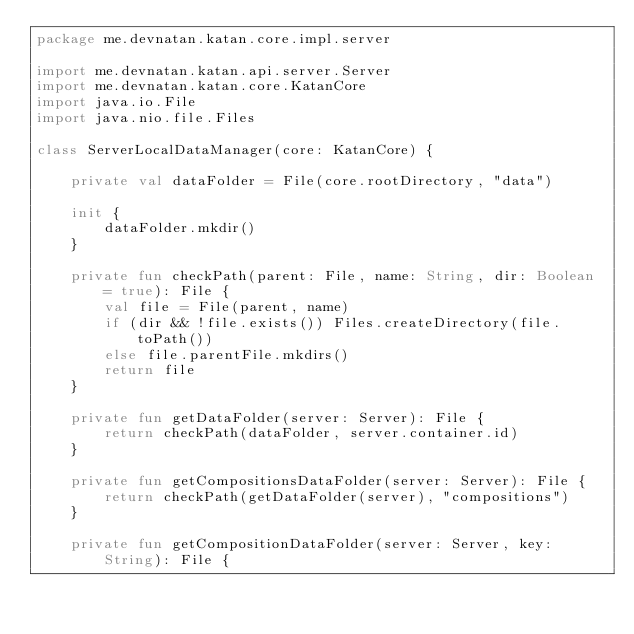<code> <loc_0><loc_0><loc_500><loc_500><_Kotlin_>package me.devnatan.katan.core.impl.server

import me.devnatan.katan.api.server.Server
import me.devnatan.katan.core.KatanCore
import java.io.File
import java.nio.file.Files

class ServerLocalDataManager(core: KatanCore) {

    private val dataFolder = File(core.rootDirectory, "data")

    init {
        dataFolder.mkdir()
    }

    private fun checkPath(parent: File, name: String, dir: Boolean = true): File {
        val file = File(parent, name)
        if (dir && !file.exists()) Files.createDirectory(file.toPath())
        else file.parentFile.mkdirs()
        return file
    }

    private fun getDataFolder(server: Server): File {
        return checkPath(dataFolder, server.container.id)
    }

    private fun getCompositionsDataFolder(server: Server): File {
        return checkPath(getDataFolder(server), "compositions")
    }

    private fun getCompositionDataFolder(server: Server, key: String): File {</code> 